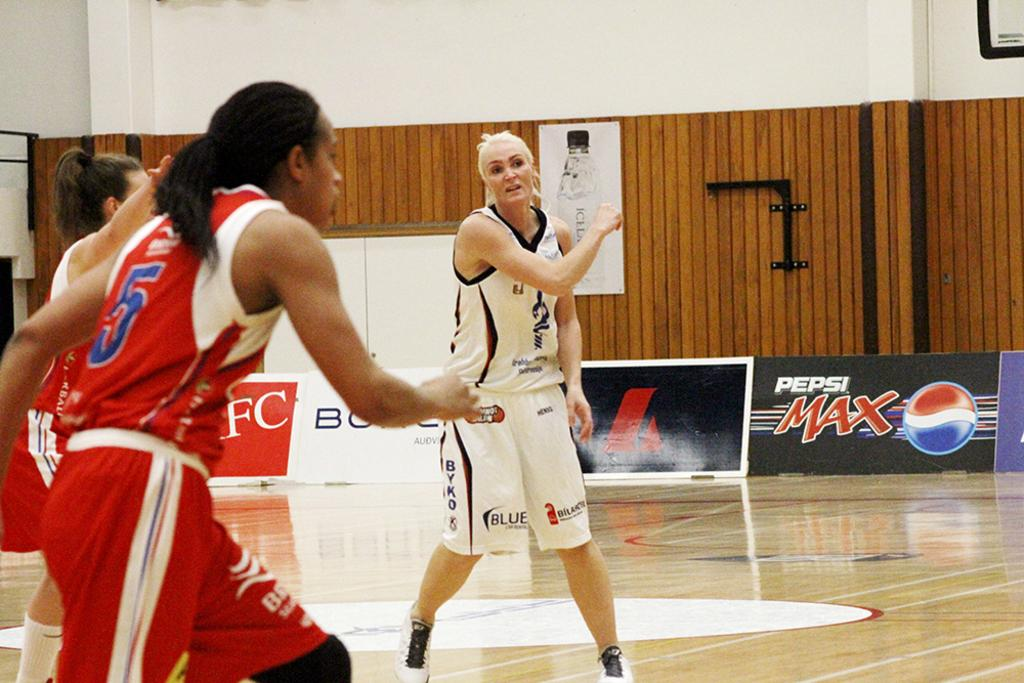<image>
Present a compact description of the photo's key features. Pepsi Max is one of the sponsors of a woman's basketball team. 